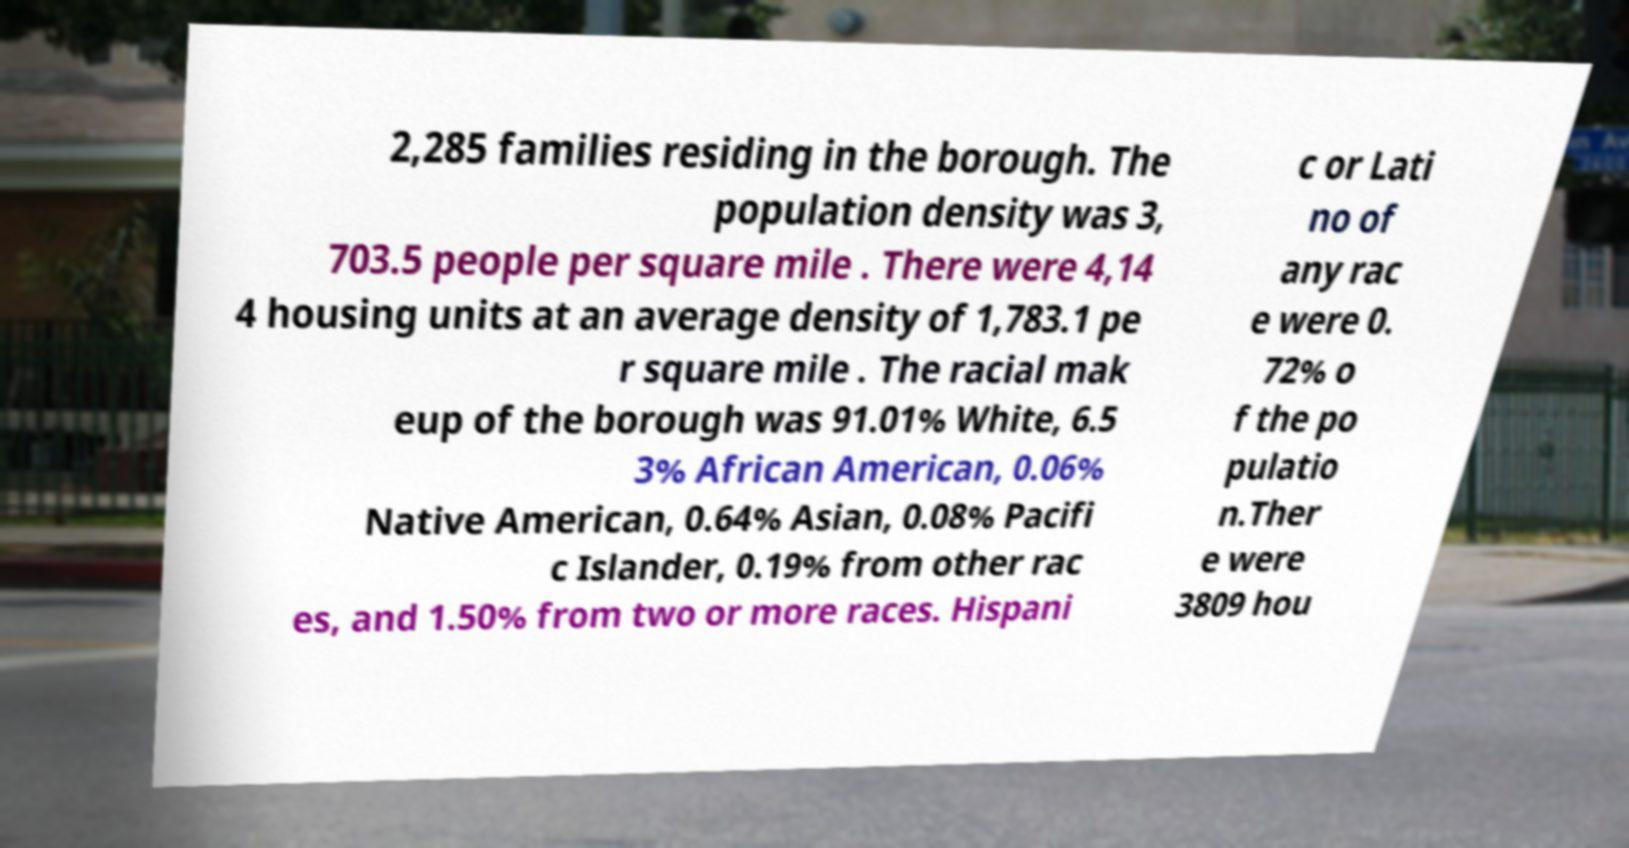Please read and relay the text visible in this image. What does it say? 2,285 families residing in the borough. The population density was 3, 703.5 people per square mile . There were 4,14 4 housing units at an average density of 1,783.1 pe r square mile . The racial mak eup of the borough was 91.01% White, 6.5 3% African American, 0.06% Native American, 0.64% Asian, 0.08% Pacifi c Islander, 0.19% from other rac es, and 1.50% from two or more races. Hispani c or Lati no of any rac e were 0. 72% o f the po pulatio n.Ther e were 3809 hou 